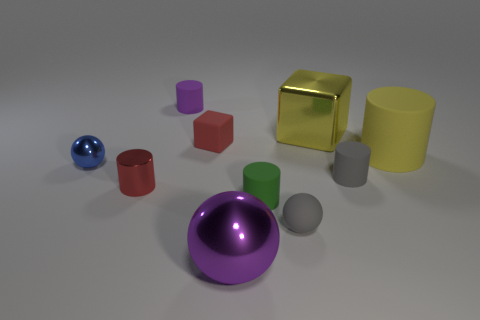How many other things are the same material as the tiny block?
Your answer should be very brief. 5. What shape is the tiny rubber thing that is the same color as the tiny metallic cylinder?
Provide a short and direct response. Cube. There is a red object behind the yellow cylinder; how big is it?
Make the answer very short. Small. There is a small blue thing that is made of the same material as the purple sphere; what shape is it?
Ensure brevity in your answer.  Sphere. Is the material of the tiny gray ball the same as the small red thing in front of the blue metallic object?
Make the answer very short. No. There is a big thing behind the tiny rubber block; is its shape the same as the large yellow matte object?
Provide a succinct answer. No. What material is the small blue object that is the same shape as the purple metal thing?
Your response must be concise. Metal. Does the blue metal thing have the same shape as the small red thing that is behind the yellow cylinder?
Offer a terse response. No. What is the color of the thing that is on the right side of the green object and behind the tiny matte cube?
Provide a succinct answer. Yellow. Is there a gray cylinder?
Provide a succinct answer. Yes. 